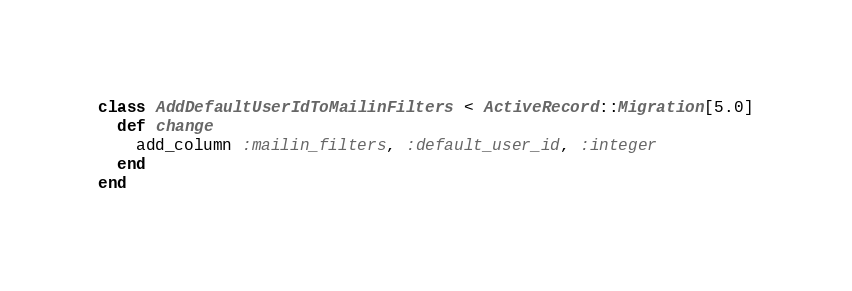Convert code to text. <code><loc_0><loc_0><loc_500><loc_500><_Ruby_>class AddDefaultUserIdToMailinFilters < ActiveRecord::Migration[5.0]
  def change
    add_column :mailin_filters, :default_user_id, :integer
  end
end
</code> 